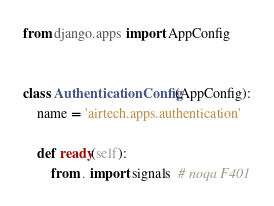<code> <loc_0><loc_0><loc_500><loc_500><_Python_>from django.apps import AppConfig


class AuthenticationConfig(AppConfig):
    name = 'airtech.apps.authentication'

    def ready(self):
        from . import signals  # noqa F401
</code> 